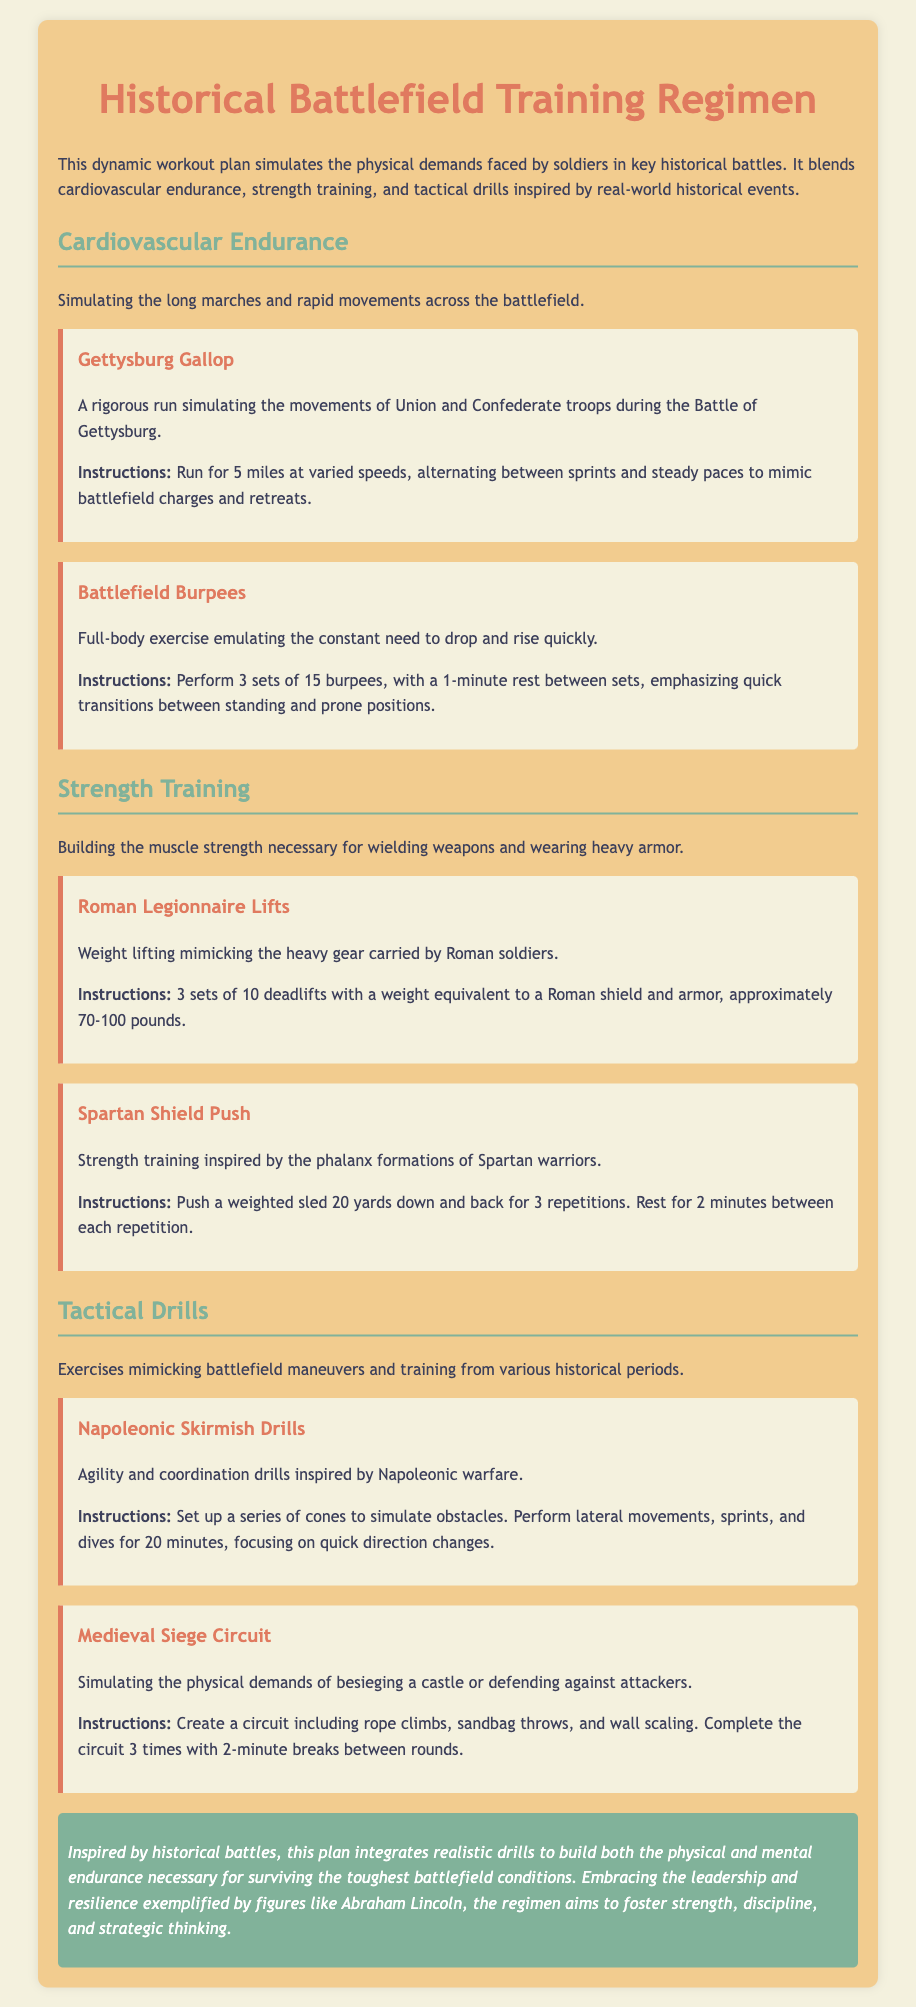What is the title of the workout plan? The title of the workout plan is stated at the top of the document, which clearly identifies its purpose.
Answer: Historical Battlefield Training Regimen What is the first exercise listed under Cardiovascular Endurance? The first exercise is the initial activity summarized in the section dedicated to cardiovascular endurance.
Answer: Gettysburg Gallop How many burpees are to be performed in Battlefield Burpees? The document specifies the number of repetitions for this exercise in its description.
Answer: 15 What type of lifts are performed in the Roman Legionnaire Lifts? The document categorizes this exercise to fit under strength training, specifically naming the lift involved.
Answer: Deadlifts How long should Napoleonic Skirmish Drills be performed? The duration for carrying out this tactical drill is mentioned in the instructions provided.
Answer: 20 minutes What weight range is recommended for the Roman Legionnaire Lifts? The document provides a specific range for the weights to be used in this strength training exercise.
Answer: 70-100 pounds What is the primary focus of the exercises in this training regimen? The document mentions the goal and overarching theme that integrates various types of training.
Answer: Physical and mental endurance How many circuits are to be completed in the Medieval Siege Circuit? The number of complete sets is explicitly outlined in the instructions for this exercise.
Answer: 3 times 